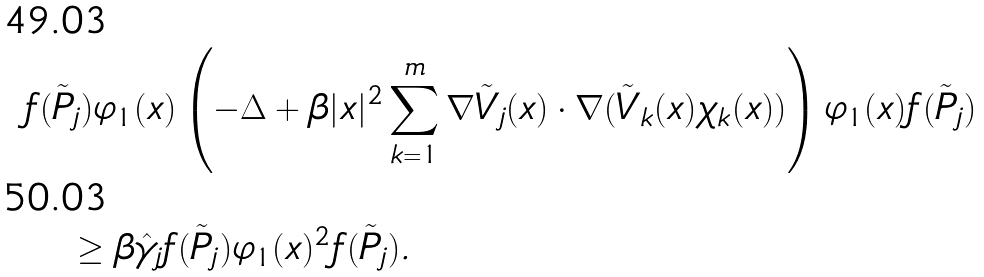Convert formula to latex. <formula><loc_0><loc_0><loc_500><loc_500>& f ( \tilde { P } _ { j } ) \varphi _ { 1 } ( x ) \left ( - \Delta + \beta | x | ^ { 2 } \sum _ { k = 1 } ^ { m } \nabla \tilde { V } _ { j } ( x ) \cdot \nabla ( \tilde { V } _ { k } ( x ) \chi _ { k } ( x ) ) \right ) \varphi _ { 1 } ( x ) f ( \tilde { P } _ { j } ) \\ & \quad \geq \beta \hat { \gamma } _ { j } f ( \tilde { P } _ { j } ) \varphi _ { 1 } ( x ) ^ { 2 } f ( \tilde { P } _ { j } ) .</formula> 